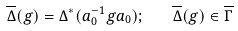<formula> <loc_0><loc_0><loc_500><loc_500>\overline { \Delta } ( g ) = \Delta ^ { \ast } ( a ^ { - 1 } _ { 0 } g a _ { 0 } ) ; \quad \overline { \Delta } ( g ) \in \overline { \Gamma }</formula> 